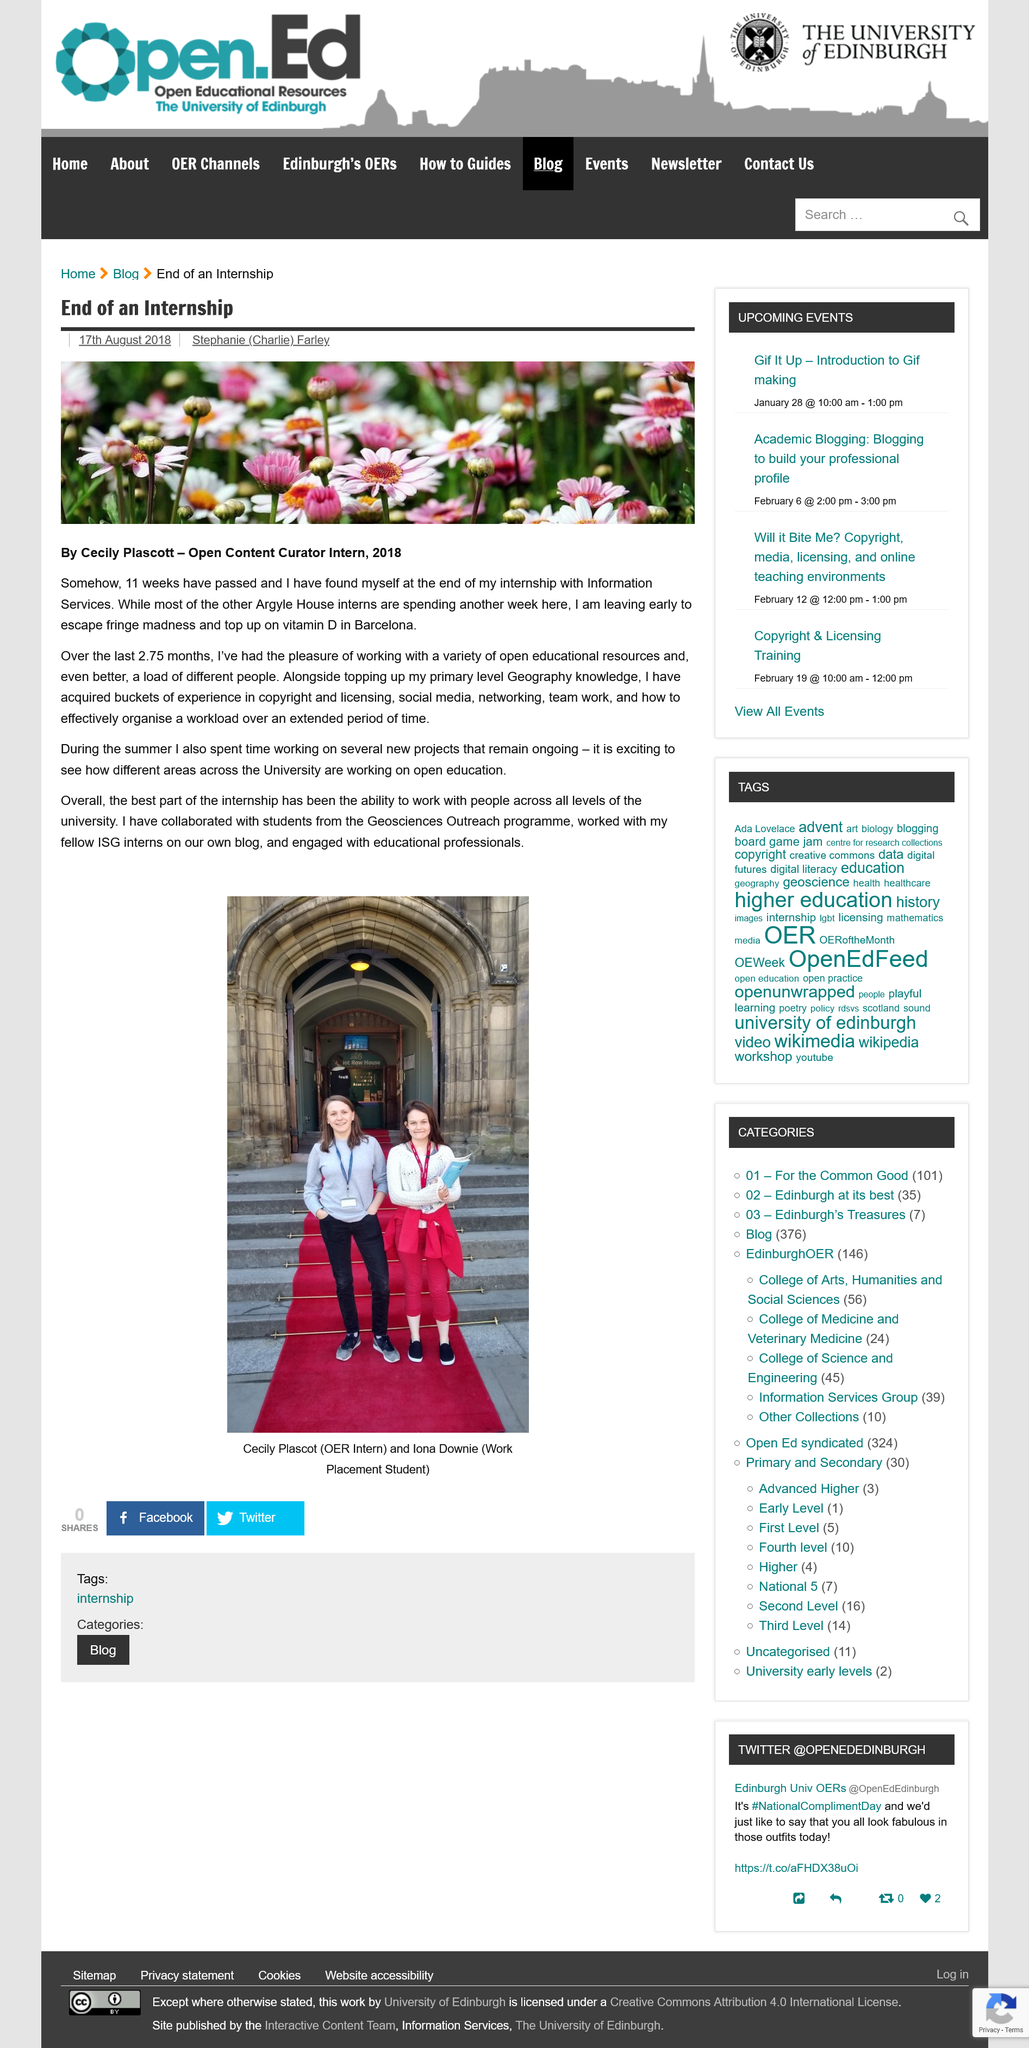Indicate a few pertinent items in this graphic. The author of the essay states that the best part of the internship was the opportunity to work with individuals of all levels within the university. This was made on August 17th, 2018. Iona Downie is wearing black shoes. The two people in the photograph are named Cecily Plascot and Iona Downie. The internship lasted for 11 weeks. 